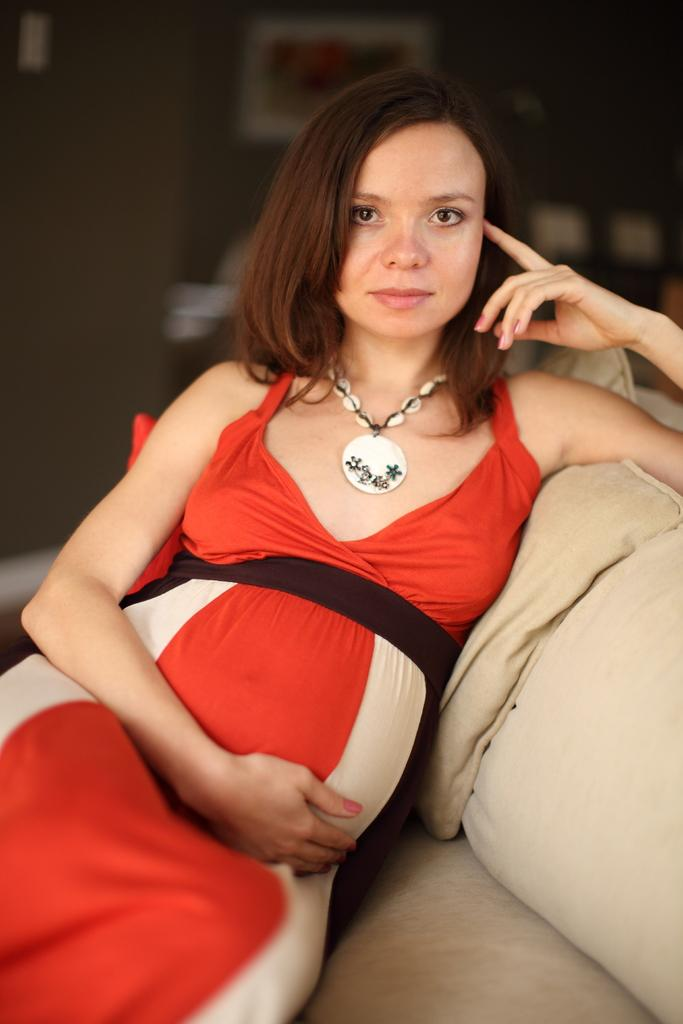Who is the main subject in the image? There is a lady in the image. What is the lady doing in the image? The lady is sitting on a sofa. Can you describe the background of the image? The background of the image is blurred. How many stars can be seen on the lady's dress in the image? There is no mention of stars or any specific details about the lady's dress in the provided facts, so we cannot determine the number of stars on her dress. 